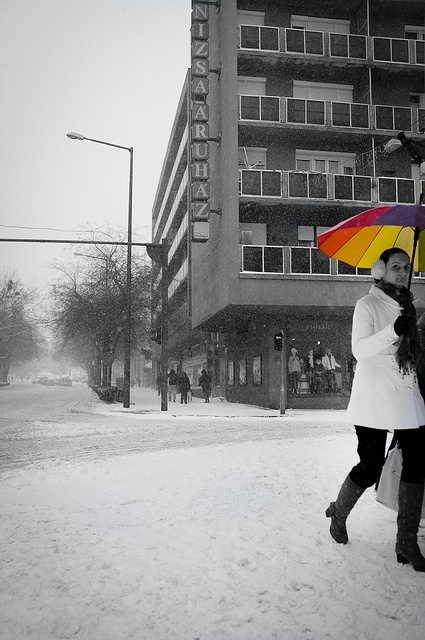Describe the objects in this image and their specific colors. I can see people in lightgray, black, darkgray, and gray tones, umbrella in lightgray, orange, brown, olive, and black tones, people in lightgray, gray, black, and darkgray tones, people in gray, black, and lightgray tones, and people in lightgray, black, gray, and darkgray tones in this image. 